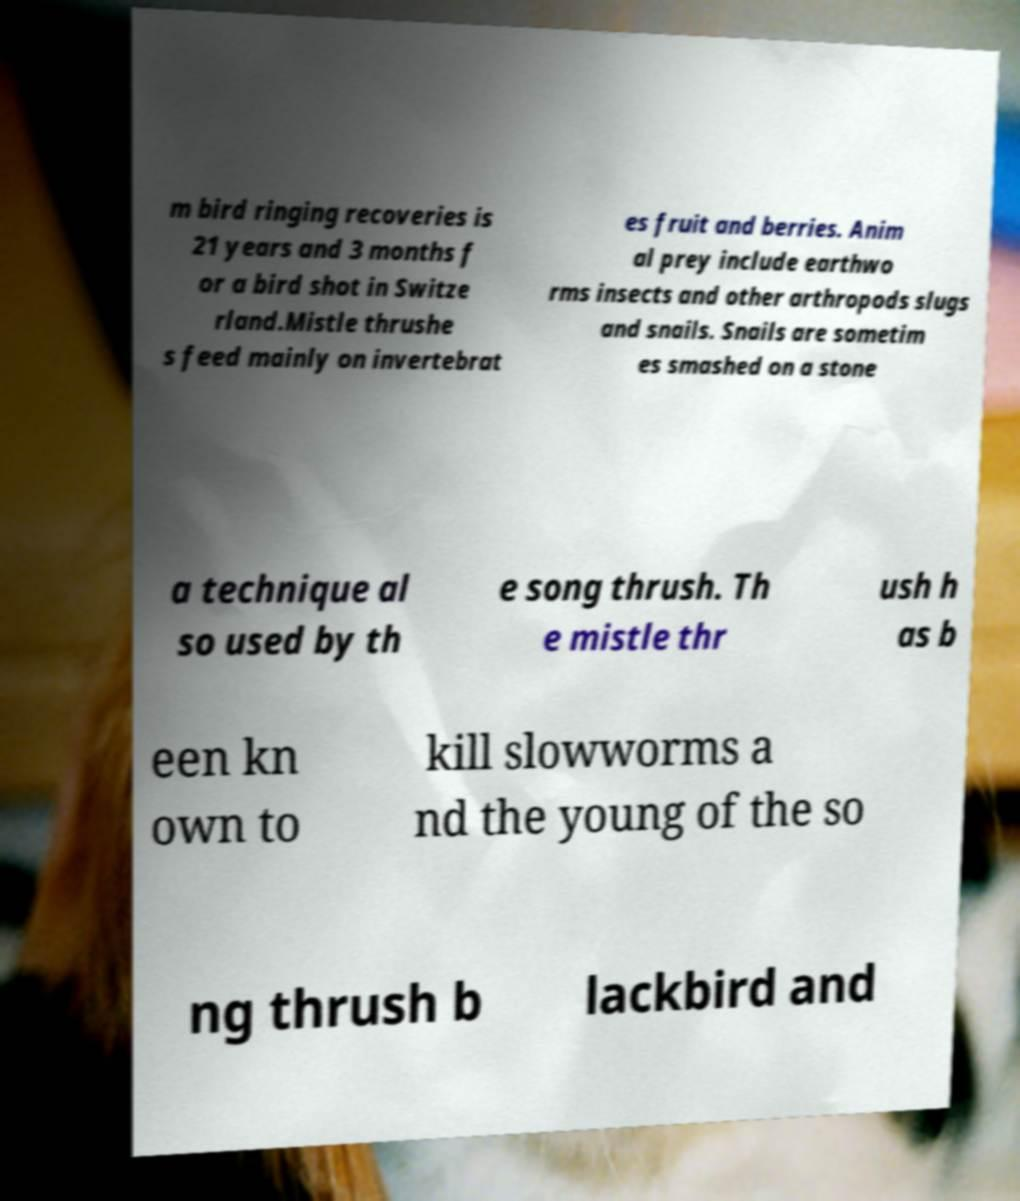I need the written content from this picture converted into text. Can you do that? m bird ringing recoveries is 21 years and 3 months f or a bird shot in Switze rland.Mistle thrushe s feed mainly on invertebrat es fruit and berries. Anim al prey include earthwo rms insects and other arthropods slugs and snails. Snails are sometim es smashed on a stone a technique al so used by th e song thrush. Th e mistle thr ush h as b een kn own to kill slowworms a nd the young of the so ng thrush b lackbird and 